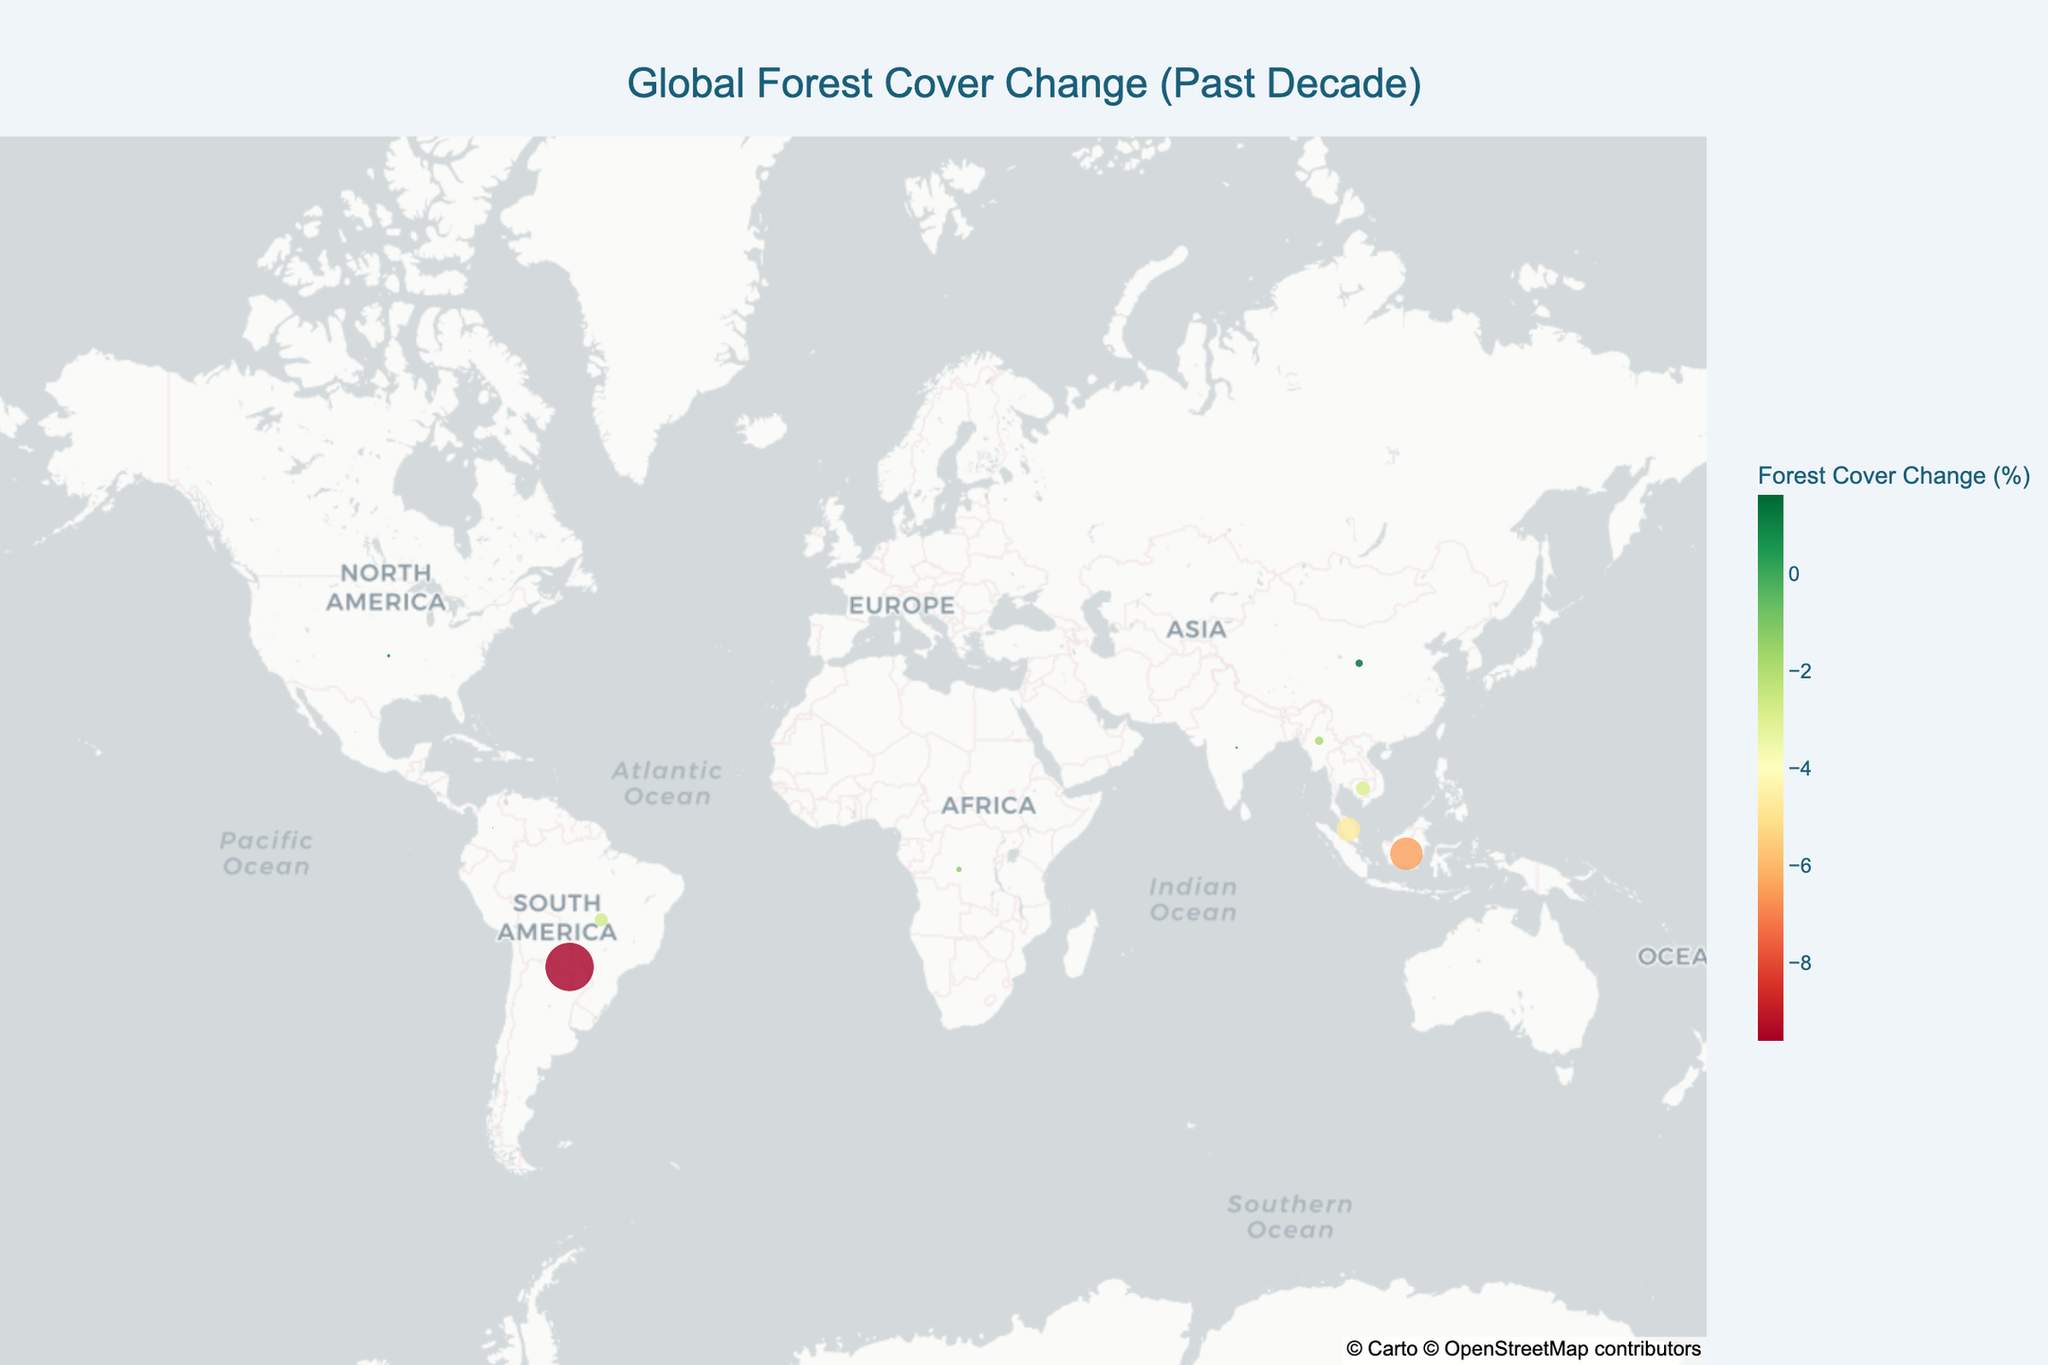What is the title of the figure? The title of the figure is shown at the top center. By reading it, we can identify the title.
Answer: Global Forest Cover Change (Past Decade) How many countries have shown a positive forest cover change? We can count the markers in the positive range on the color scale (green side). These countries are Canada, United States, Russia, China, and India.
Answer: 5 Which country experienced the highest percentage decrease in forest cover? By looking at the color scale and the tooltip text for the different markers, it becomes clear that Paraguay experienced the highest forest cover decline at -9.6%.
Answer: Paraguay What is the total area of deforestation in Brazil and Indonesia combined? By adding the deforestation area for Brazil (33000 sq km) and Indonesia (9500 sq km), we get the total. 33000 + 9500 = 42500 sq km.
Answer: 42500 sq km Which countries have more positive (green) markers representing reforestation? We identify and count the markers representing each country with positive forest cover change percentages. These countries are Canada, United States, Russia, China, and India.
Answer: 5 How does the forest cover change in India compare to that in China? By comparing the markers for India and China, we see that India has a forest cover change of 0.6%, while China has 1.6%. Thus, China has a greater positive forest cover change than India.
Answer: China's forest cover change is greater Which country has the smallest deforestation area, and what is its reforestation area? By inspecting the tooltip text for each marker, we see that India has the smallest deforestation area of 100 sq km and a reforestation area of 2800 sq km.
Answer: India, 2800 sq km What is the average forest cover change percentage among the countries listed? Summing all forest cover change percentages and dividing by the number of countries: (-2.7 - 6.5 - 1.2 - 4.7 - 9.6 - 0.4 - 0.2 - 0.3 - 1.8 - 2.9 + 0.1 + 0.8 + 0.2 + 1.6 + 0.6) / 15 = -29.0 / 15 ≈ -1.93%.
Answer: -1.93% What is the combined reforestation area for the United States and China? By adding the reforestation area for the United States (2200 sq km) and China (5000 sq km), we obtain the total. 2200 + 5000 = 7200 sq km.
Answer: 7200 sq km 